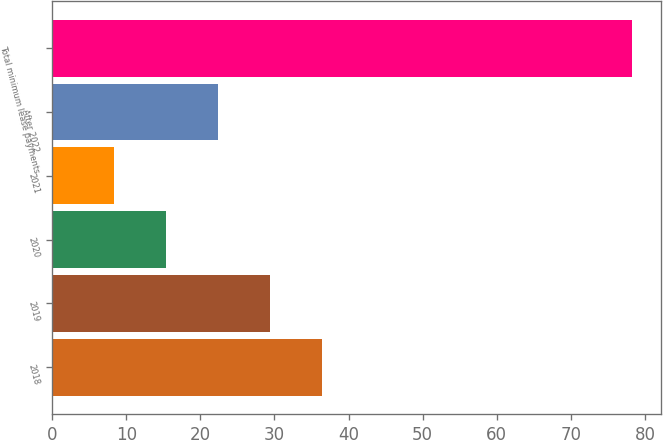Convert chart to OTSL. <chart><loc_0><loc_0><loc_500><loc_500><bar_chart><fcel>2018<fcel>2019<fcel>2020<fcel>2021<fcel>After 2022<fcel>Total minimum lease payments<nl><fcel>36.36<fcel>29.37<fcel>15.39<fcel>8.4<fcel>22.38<fcel>78.3<nl></chart> 